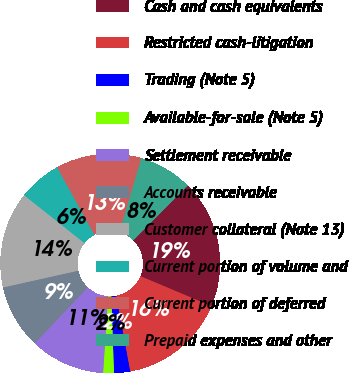Convert chart. <chart><loc_0><loc_0><loc_500><loc_500><pie_chart><fcel>Cash and cash equivalents<fcel>Restricted cash-litigation<fcel>Trading (Note 5)<fcel>Available-for-sale (Note 5)<fcel>Settlement receivable<fcel>Accounts receivable<fcel>Customer collateral (Note 13)<fcel>Current portion of volume and<fcel>Current portion of deferred<fcel>Prepaid expenses and other<nl><fcel>18.9%<fcel>15.75%<fcel>2.36%<fcel>1.58%<fcel>11.02%<fcel>9.45%<fcel>14.17%<fcel>6.3%<fcel>12.6%<fcel>7.87%<nl></chart> 